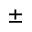Convert formula to latex. <formula><loc_0><loc_0><loc_500><loc_500>\pm</formula> 